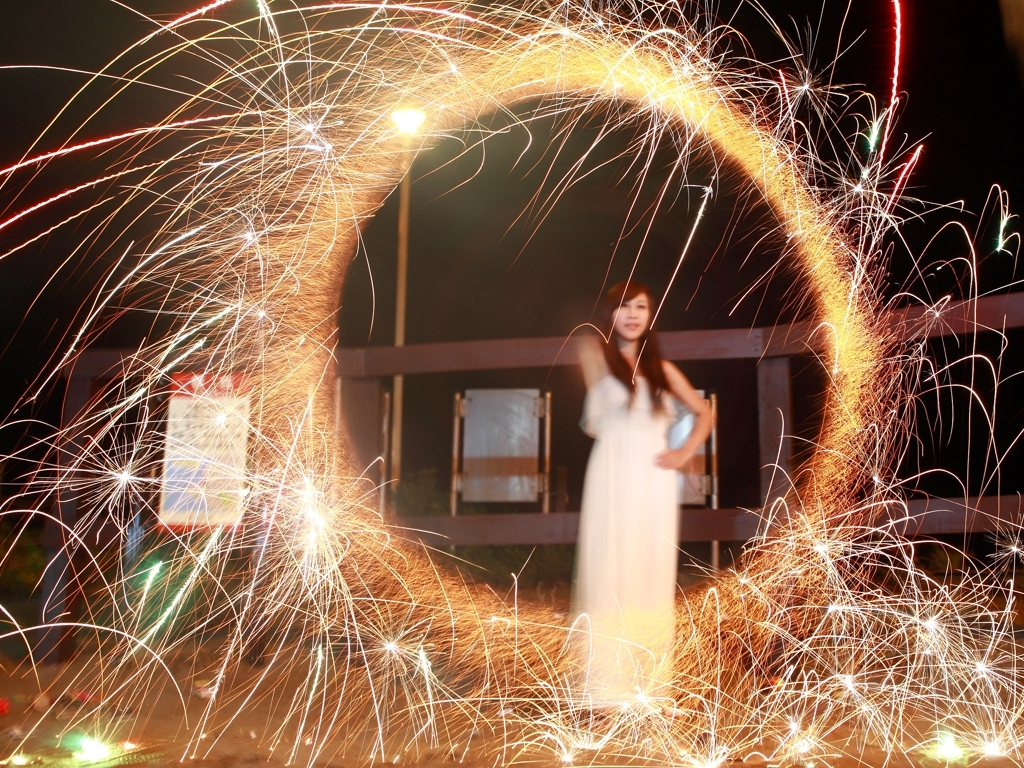What is the quality of this image?
A. Excellent
B. Poor
C. Acceptable
D. Outstanding
Answer with the option's letter from the given choices directly. While the response given was 'C. Acceptable', upon reviewing the image, the quality could be considered higher than 'acceptable' due to its creative composition and interesting use of light through long exposure. However, there is noticeable blur on the person, and the overall focus could be improved. Therefore, a more suitable answer might be 'The image has captivating elements with the use of light and could be deemed as good; nevertheless, due to the blur evident, particularly on the person, its quality does not quite reach 'excellent' or 'outstanding'. Therefore, I would rate it between 'acceptable' and 'good'. 